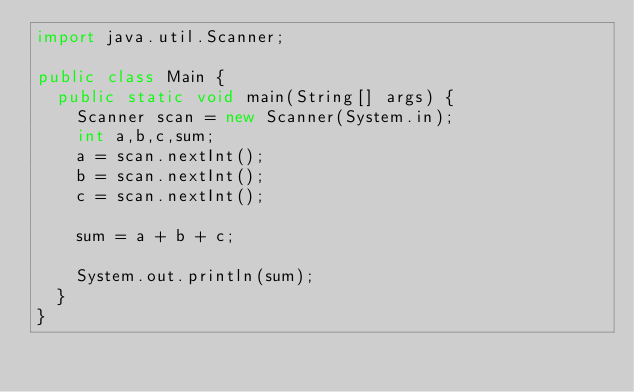<code> <loc_0><loc_0><loc_500><loc_500><_Java_>import java.util.Scanner;

public class Main {
	public static void main(String[] args) {
		Scanner scan = new Scanner(System.in);
		int a,b,c,sum;
		a = scan.nextInt();
		b = scan.nextInt();
		c = scan.nextInt();
		
		sum = a + b + c;
		
		System.out.println(sum);
	}
}
</code> 